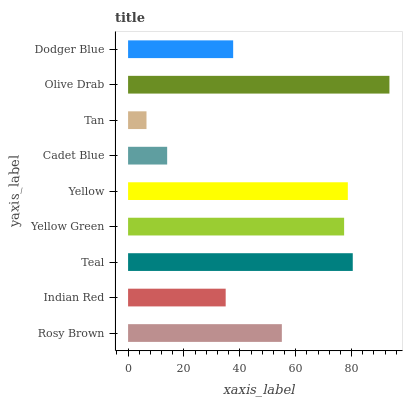Is Tan the minimum?
Answer yes or no. Yes. Is Olive Drab the maximum?
Answer yes or no. Yes. Is Indian Red the minimum?
Answer yes or no. No. Is Indian Red the maximum?
Answer yes or no. No. Is Rosy Brown greater than Indian Red?
Answer yes or no. Yes. Is Indian Red less than Rosy Brown?
Answer yes or no. Yes. Is Indian Red greater than Rosy Brown?
Answer yes or no. No. Is Rosy Brown less than Indian Red?
Answer yes or no. No. Is Rosy Brown the high median?
Answer yes or no. Yes. Is Rosy Brown the low median?
Answer yes or no. Yes. Is Yellow the high median?
Answer yes or no. No. Is Indian Red the low median?
Answer yes or no. No. 